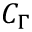Convert formula to latex. <formula><loc_0><loc_0><loc_500><loc_500>C _ { \Gamma }</formula> 